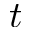<formula> <loc_0><loc_0><loc_500><loc_500>t</formula> 